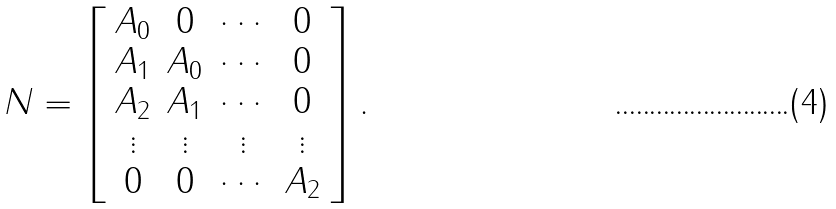Convert formula to latex. <formula><loc_0><loc_0><loc_500><loc_500>N = \left [ \begin{array} { c c c c } A _ { 0 } & 0 & \cdots & 0 \\ A _ { 1 } & A _ { 0 } & \cdots & 0 \\ A _ { 2 } & A _ { 1 } & \cdots & 0 \\ \vdots & \vdots & \vdots & \vdots \\ 0 & 0 & \cdots & A _ { 2 } \end{array} \right ] .</formula> 